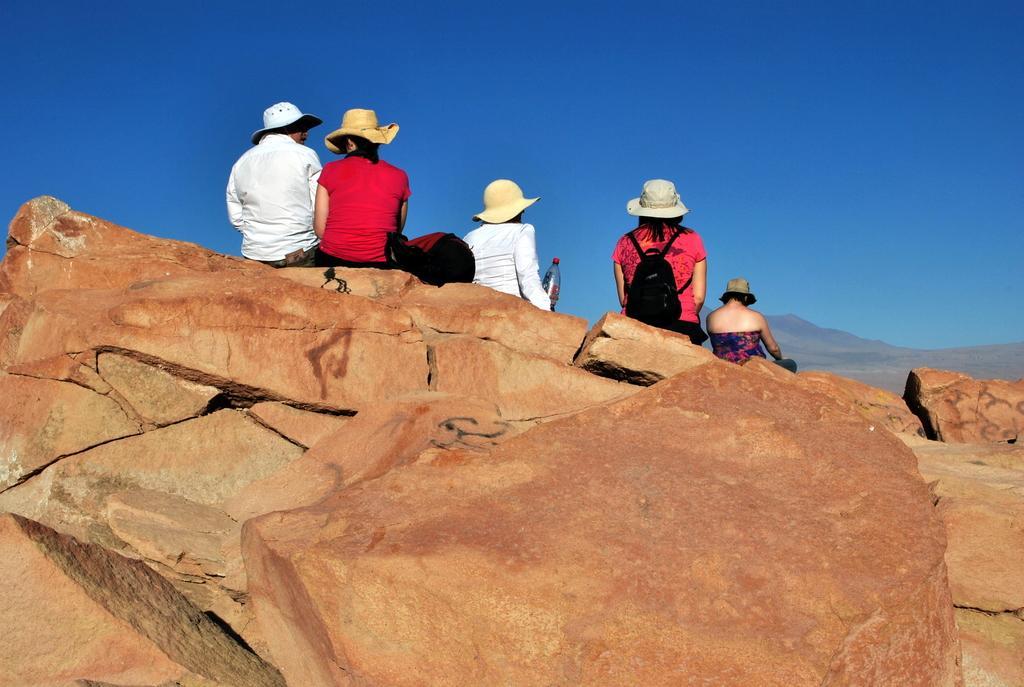In one or two sentences, can you explain what this image depicts? In this image we can see a few people wearing hats and sitting on the rocks, there are mountains, also we can see a bottle and a bag, in the background, we can see the sky. 